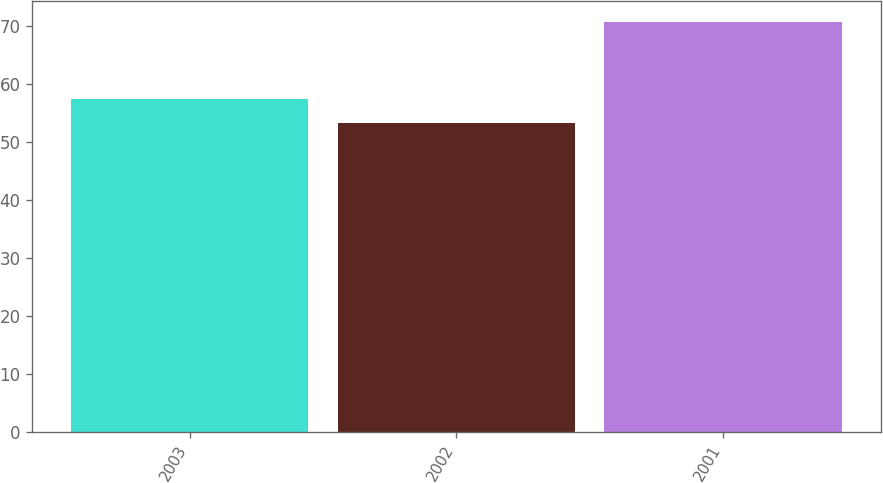<chart> <loc_0><loc_0><loc_500><loc_500><bar_chart><fcel>2003<fcel>2002<fcel>2001<nl><fcel>57.4<fcel>53.3<fcel>70.8<nl></chart> 